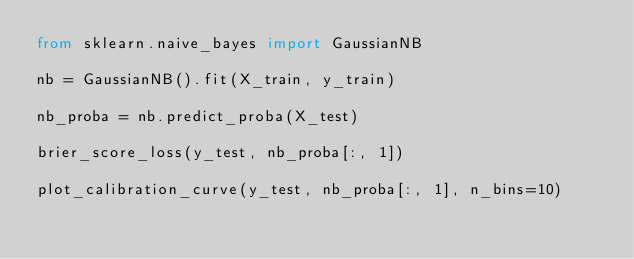Convert code to text. <code><loc_0><loc_0><loc_500><loc_500><_Python_>from sklearn.naive_bayes import GaussianNB

nb = GaussianNB().fit(X_train, y_train)

nb_proba = nb.predict_proba(X_test)

brier_score_loss(y_test, nb_proba[:, 1])

plot_calibration_curve(y_test, nb_proba[:, 1], n_bins=10)
</code> 